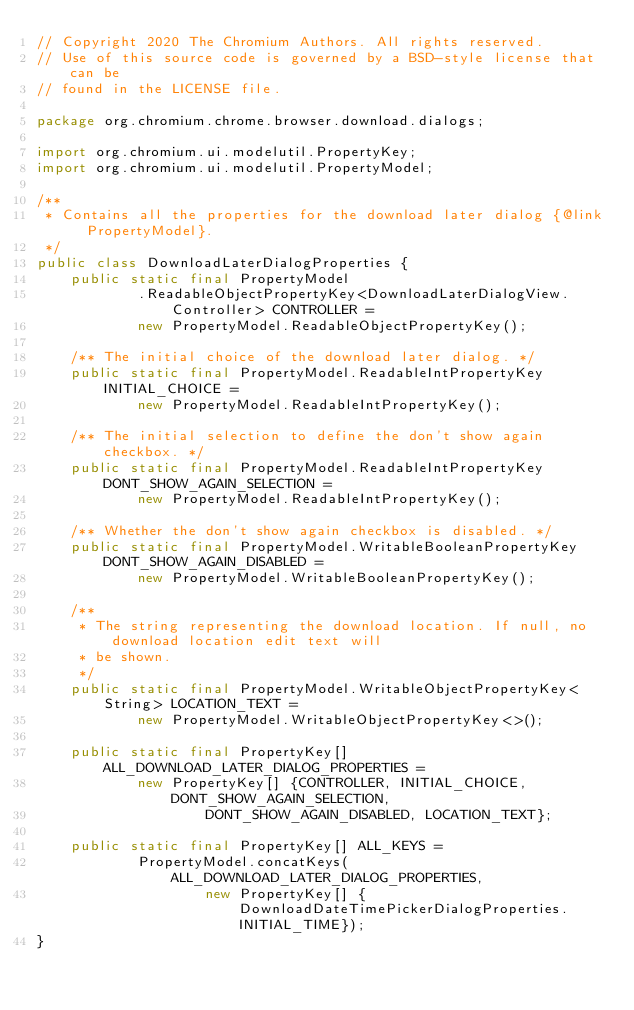<code> <loc_0><loc_0><loc_500><loc_500><_Java_>// Copyright 2020 The Chromium Authors. All rights reserved.
// Use of this source code is governed by a BSD-style license that can be
// found in the LICENSE file.

package org.chromium.chrome.browser.download.dialogs;

import org.chromium.ui.modelutil.PropertyKey;
import org.chromium.ui.modelutil.PropertyModel;

/**
 * Contains all the properties for the download later dialog {@link PropertyModel}.
 */
public class DownloadLaterDialogProperties {
    public static final PropertyModel
            .ReadableObjectPropertyKey<DownloadLaterDialogView.Controller> CONTROLLER =
            new PropertyModel.ReadableObjectPropertyKey();

    /** The initial choice of the download later dialog. */
    public static final PropertyModel.ReadableIntPropertyKey INITIAL_CHOICE =
            new PropertyModel.ReadableIntPropertyKey();

    /** The initial selection to define the don't show again checkbox. */
    public static final PropertyModel.ReadableIntPropertyKey DONT_SHOW_AGAIN_SELECTION =
            new PropertyModel.ReadableIntPropertyKey();

    /** Whether the don't show again checkbox is disabled. */
    public static final PropertyModel.WritableBooleanPropertyKey DONT_SHOW_AGAIN_DISABLED =
            new PropertyModel.WritableBooleanPropertyKey();

    /**
     * The string representing the download location. If null, no download location edit text will
     * be shown.
     */
    public static final PropertyModel.WritableObjectPropertyKey<String> LOCATION_TEXT =
            new PropertyModel.WritableObjectPropertyKey<>();

    public static final PropertyKey[] ALL_DOWNLOAD_LATER_DIALOG_PROPERTIES =
            new PropertyKey[] {CONTROLLER, INITIAL_CHOICE, DONT_SHOW_AGAIN_SELECTION,
                    DONT_SHOW_AGAIN_DISABLED, LOCATION_TEXT};

    public static final PropertyKey[] ALL_KEYS =
            PropertyModel.concatKeys(ALL_DOWNLOAD_LATER_DIALOG_PROPERTIES,
                    new PropertyKey[] {DownloadDateTimePickerDialogProperties.INITIAL_TIME});
}
</code> 